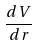<formula> <loc_0><loc_0><loc_500><loc_500>\frac { d V } { d r }</formula> 